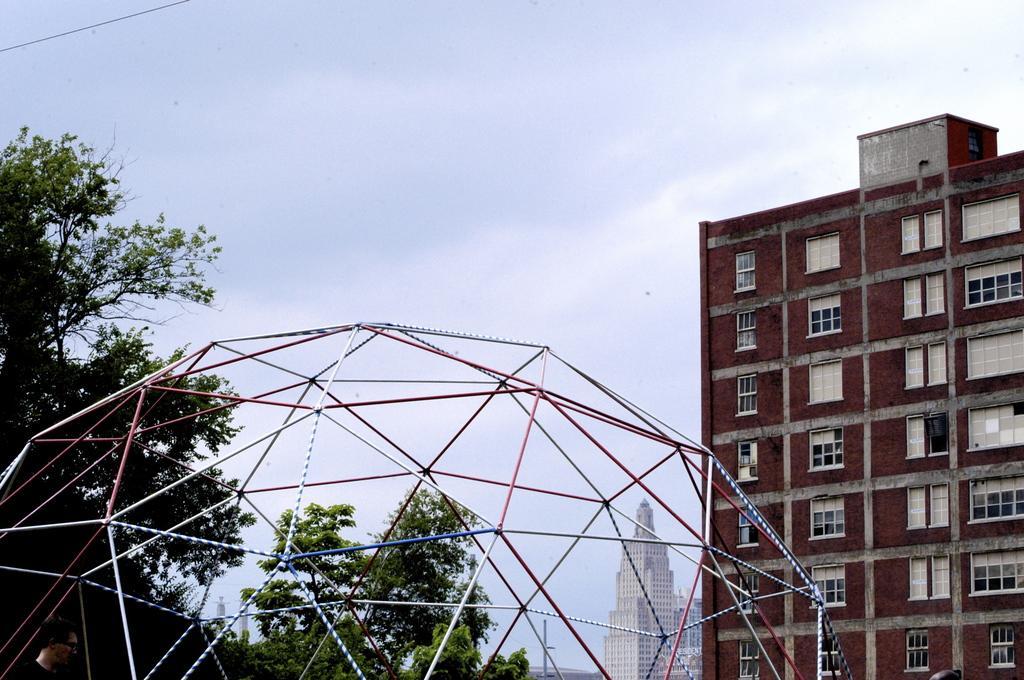How would you summarize this image in a sentence or two? In the picture we can see a pole design and behind it, we can see a part of the trees and opposite side of it, we can see the building with windows and beside it, we can see a tower building and in the background we can see the sky with clouds. 